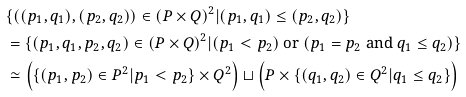<formula> <loc_0><loc_0><loc_500><loc_500>& \{ ( ( p _ { 1 } , q _ { 1 } ) , ( p _ { 2 } , q _ { 2 } ) ) \in ( P \times Q ) ^ { 2 } | ( p _ { 1 } , q _ { 1 } ) \leq ( p _ { 2 } , q _ { 2 } ) \} \\ & = \{ ( p _ { 1 } , q _ { 1 } , p _ { 2 } , q _ { 2 } ) \in ( P \times Q ) ^ { 2 } | ( p _ { 1 } < p _ { 2 } ) \text { or } ( p _ { 1 } = p _ { 2 } \text { and } q _ { 1 } \leq q _ { 2 } ) \} \\ & \simeq \left ( \{ ( p _ { 1 } , p _ { 2 } ) \in P ^ { 2 } | p _ { 1 } < p _ { 2 } \} \times Q ^ { 2 } \right ) \sqcup \left ( P \times \{ ( q _ { 1 } , q _ { 2 } ) \in Q ^ { 2 } | q _ { 1 } \leq q _ { 2 } \} \right )</formula> 